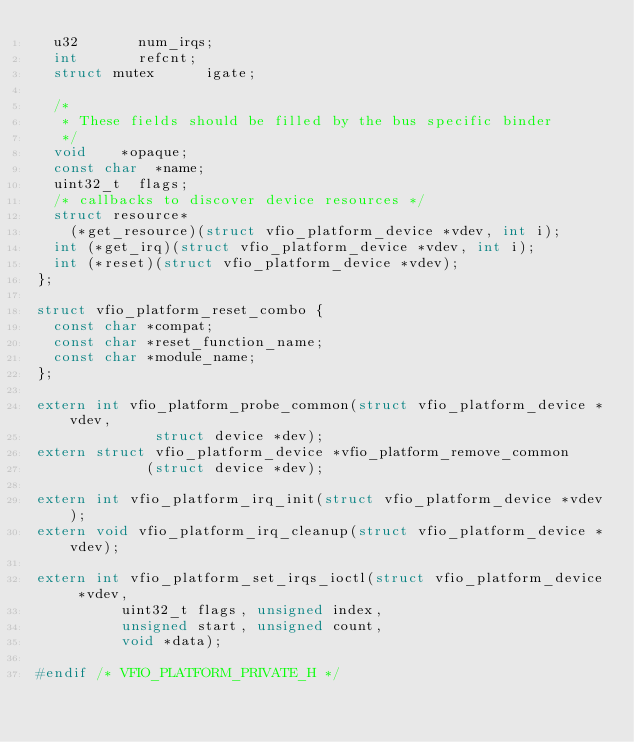<code> <loc_0><loc_0><loc_500><loc_500><_C_>	u32				num_irqs;
	int				refcnt;
	struct mutex			igate;

	/*
	 * These fields should be filled by the bus specific binder
	 */
	void		*opaque;
	const char	*name;
	uint32_t	flags;
	/* callbacks to discover device resources */
	struct resource*
		(*get_resource)(struct vfio_platform_device *vdev, int i);
	int	(*get_irq)(struct vfio_platform_device *vdev, int i);
	int	(*reset)(struct vfio_platform_device *vdev);
};

struct vfio_platform_reset_combo {
	const char *compat;
	const char *reset_function_name;
	const char *module_name;
};

extern int vfio_platform_probe_common(struct vfio_platform_device *vdev,
				      struct device *dev);
extern struct vfio_platform_device *vfio_platform_remove_common
				     (struct device *dev);

extern int vfio_platform_irq_init(struct vfio_platform_device *vdev);
extern void vfio_platform_irq_cleanup(struct vfio_platform_device *vdev);

extern int vfio_platform_set_irqs_ioctl(struct vfio_platform_device *vdev,
					uint32_t flags, unsigned index,
					unsigned start, unsigned count,
					void *data);

#endif /* VFIO_PLATFORM_PRIVATE_H */
</code> 